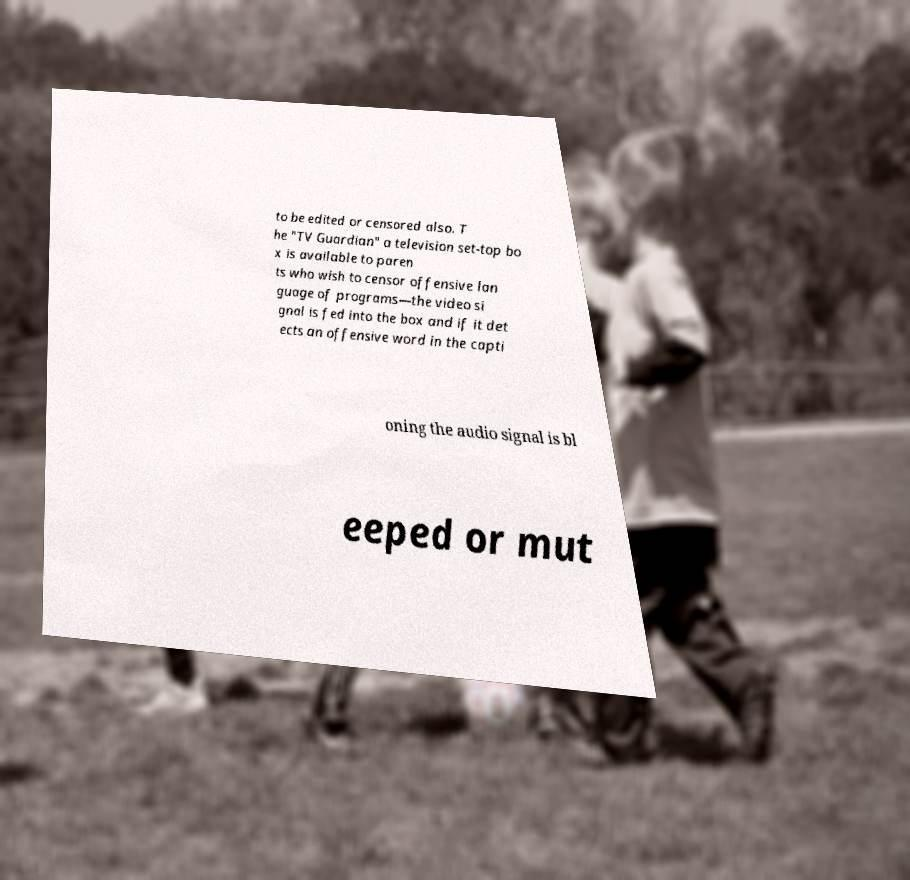What messages or text are displayed in this image? I need them in a readable, typed format. to be edited or censored also. T he "TV Guardian" a television set-top bo x is available to paren ts who wish to censor offensive lan guage of programs—the video si gnal is fed into the box and if it det ects an offensive word in the capti oning the audio signal is bl eeped or mut 